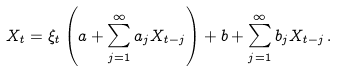Convert formula to latex. <formula><loc_0><loc_0><loc_500><loc_500>X _ { t } = \xi _ { t } \left ( a + \sum _ { j = 1 } ^ { \infty } a _ { j } X _ { t - j } \right ) + b + \sum _ { j = 1 } ^ { \infty } b _ { j } X _ { t - j } \, .</formula> 